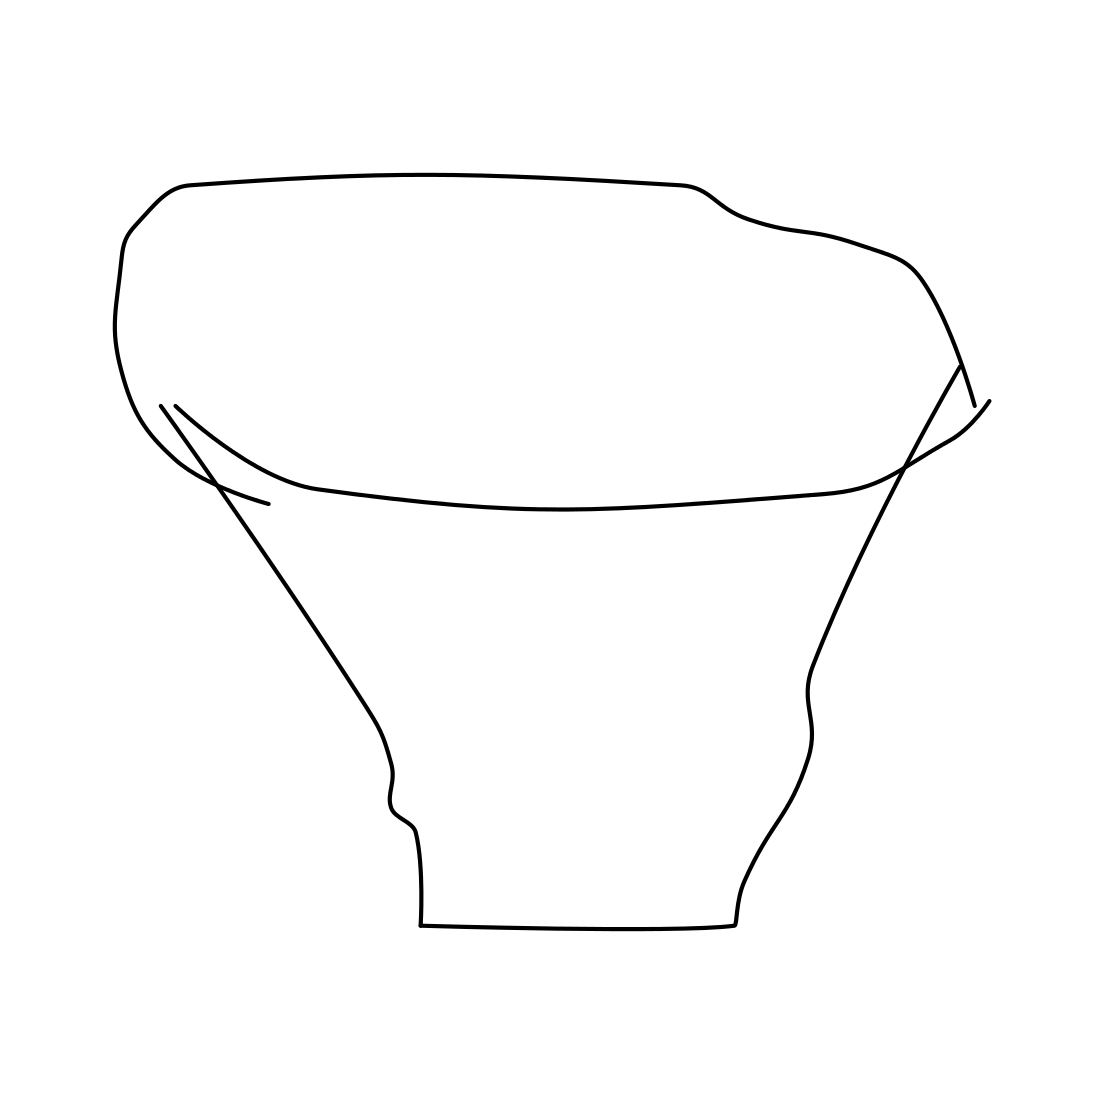Is there anything on the pot that could be considered decorative? No, there are no decorative elements visible on the pot. The drawing is very simplistic and does not include any ornamentation, patterns, or embellishments that would usually serve a decorative purpose. 